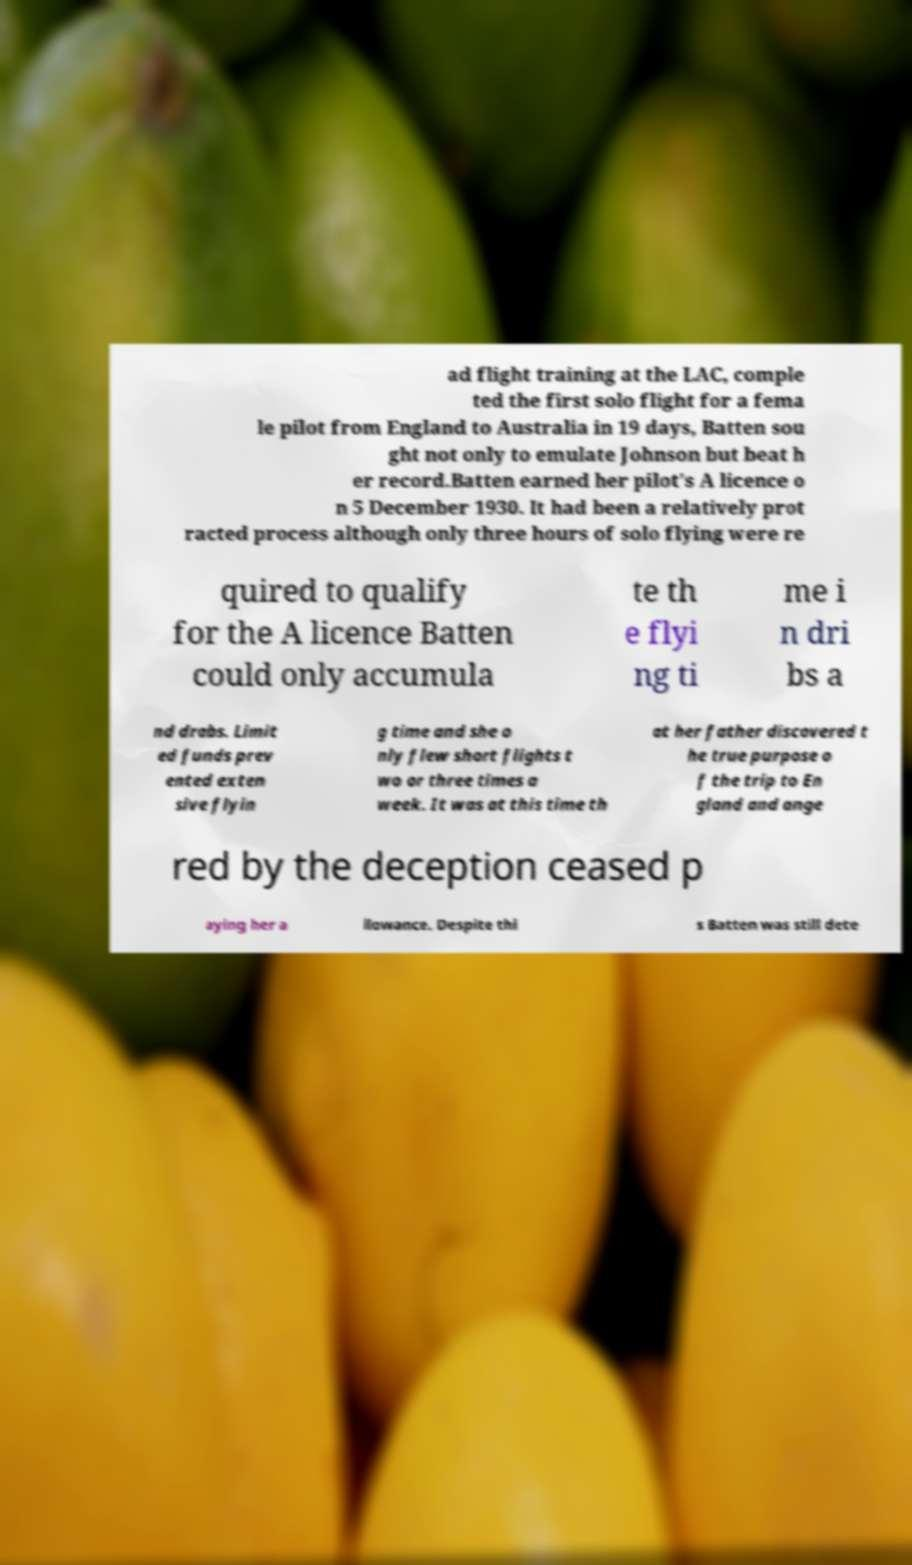Could you extract and type out the text from this image? ad flight training at the LAC, comple ted the first solo flight for a fema le pilot from England to Australia in 19 days, Batten sou ght not only to emulate Johnson but beat h er record.Batten earned her pilot's A licence o n 5 December 1930. It had been a relatively prot racted process although only three hours of solo flying were re quired to qualify for the A licence Batten could only accumula te th e flyi ng ti me i n dri bs a nd drabs. Limit ed funds prev ented exten sive flyin g time and she o nly flew short flights t wo or three times a week. It was at this time th at her father discovered t he true purpose o f the trip to En gland and ange red by the deception ceased p aying her a llowance. Despite thi s Batten was still dete 